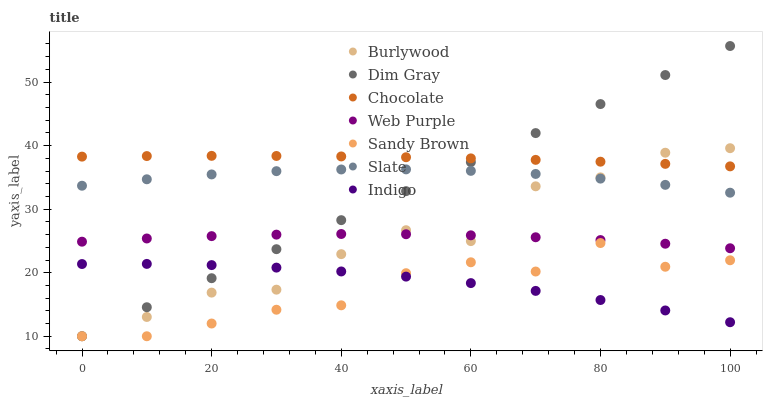Does Sandy Brown have the minimum area under the curve?
Answer yes or no. Yes. Does Chocolate have the maximum area under the curve?
Answer yes or no. Yes. Does Indigo have the minimum area under the curve?
Answer yes or no. No. Does Indigo have the maximum area under the curve?
Answer yes or no. No. Is Dim Gray the smoothest?
Answer yes or no. Yes. Is Burlywood the roughest?
Answer yes or no. Yes. Is Indigo the smoothest?
Answer yes or no. No. Is Indigo the roughest?
Answer yes or no. No. Does Dim Gray have the lowest value?
Answer yes or no. Yes. Does Indigo have the lowest value?
Answer yes or no. No. Does Dim Gray have the highest value?
Answer yes or no. Yes. Does Burlywood have the highest value?
Answer yes or no. No. Is Indigo less than Web Purple?
Answer yes or no. Yes. Is Chocolate greater than Sandy Brown?
Answer yes or no. Yes. Does Burlywood intersect Slate?
Answer yes or no. Yes. Is Burlywood less than Slate?
Answer yes or no. No. Is Burlywood greater than Slate?
Answer yes or no. No. Does Indigo intersect Web Purple?
Answer yes or no. No. 